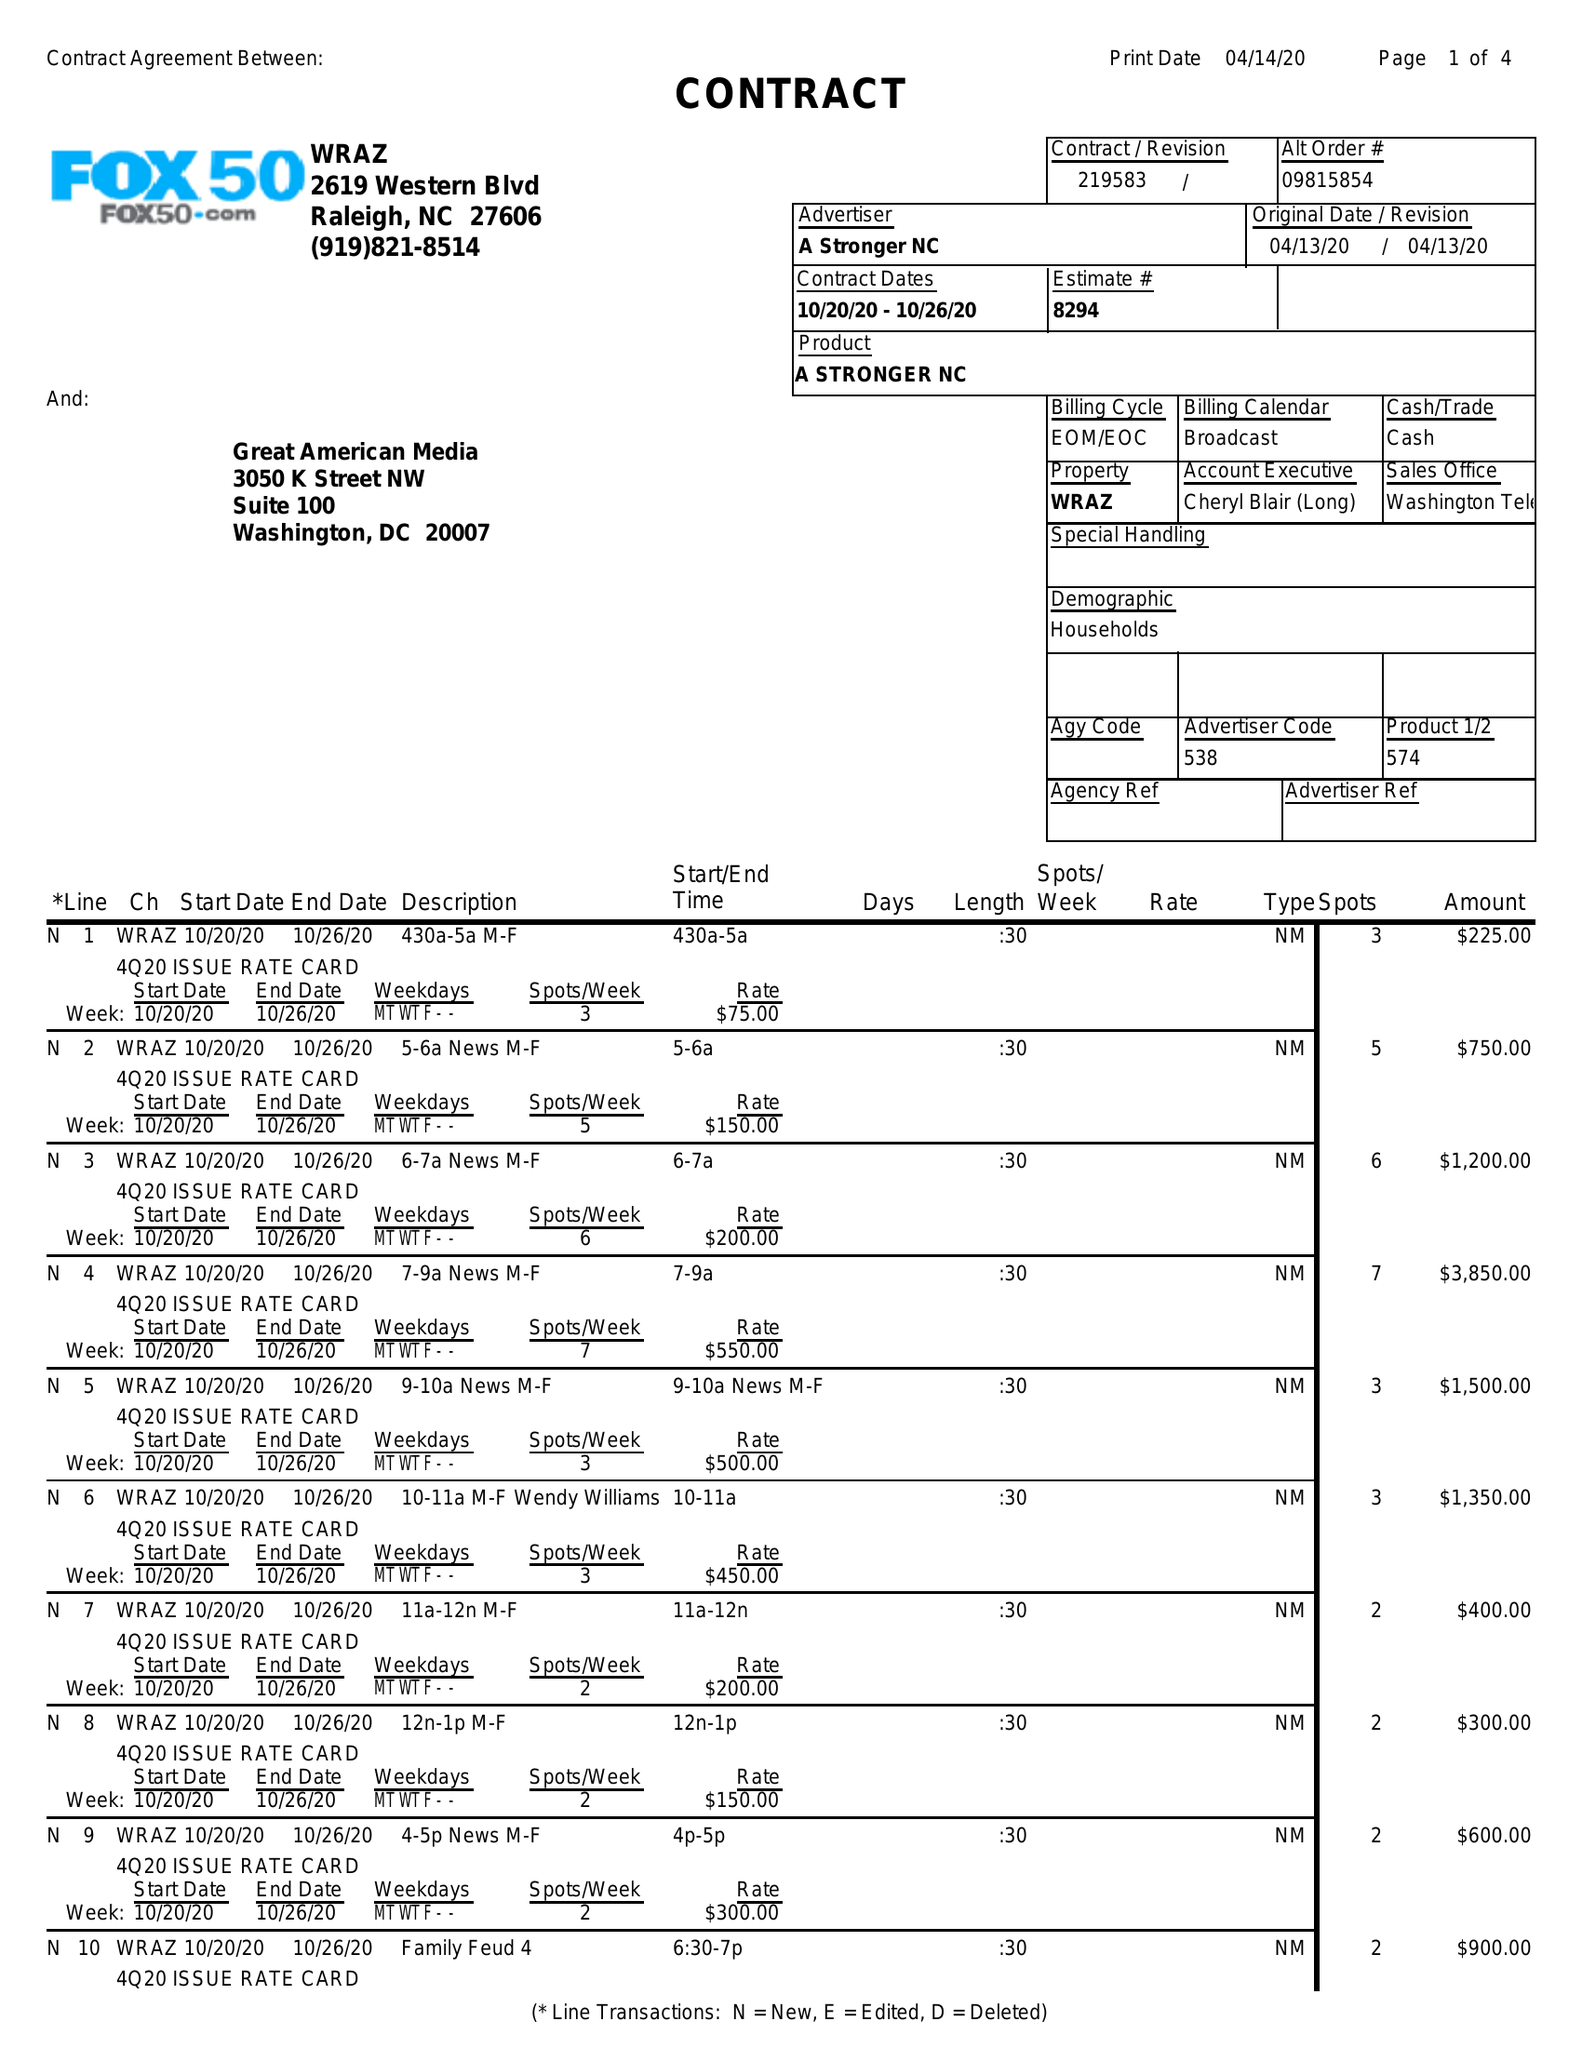What is the value for the contract_num?
Answer the question using a single word or phrase. 219583 